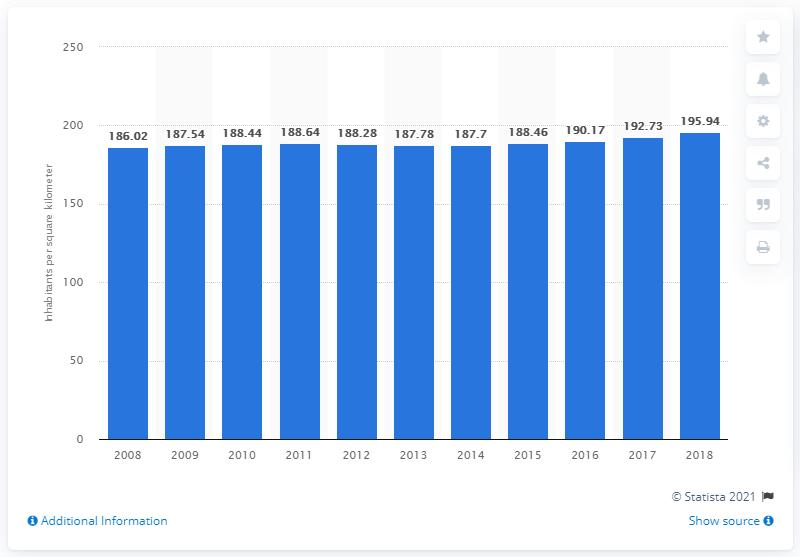Give some essential details in this illustration. In 2018, the population density in Nepal was estimated to be 195.94 people per square kilometer. 